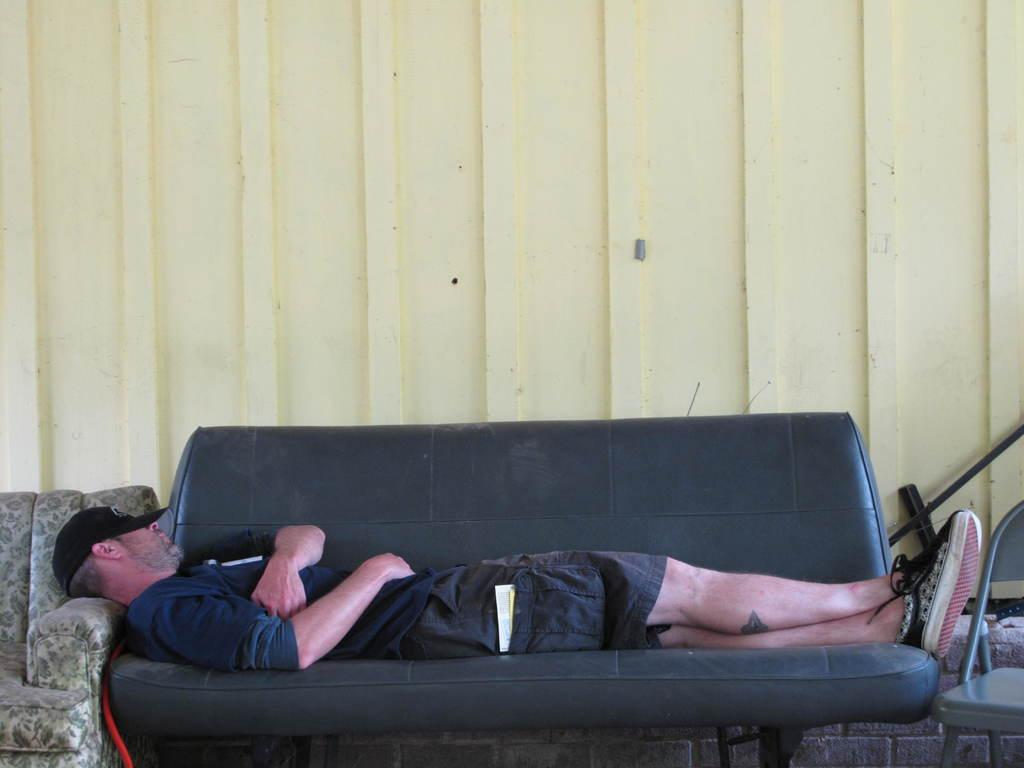What type of furniture is in the image? There is a couch in the image. What is the man in the image doing? A man is lying on the couch. What other piece of furniture can be seen in the image? There is a chair on the right side of the image. What color is the wall in the background of the image? There is a white-colored wall in the background of the image. What type of nail is the man using to hang a picture on the wall in the image? There is no nail or picture hanging activity present in the image. 